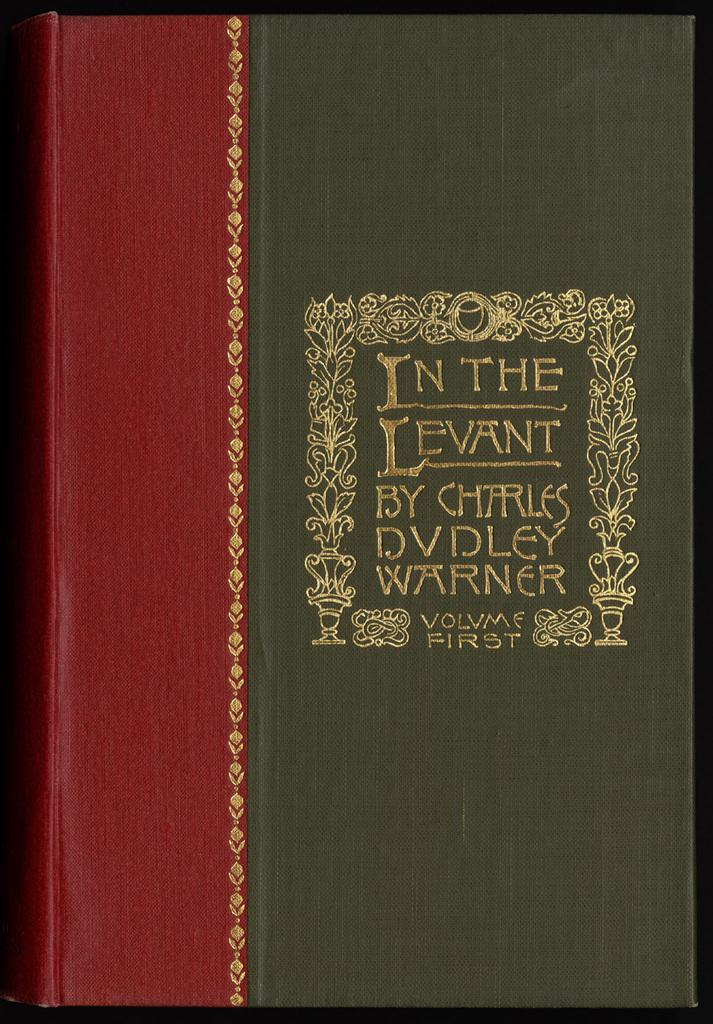<image>
Create a compact narrative representing the image presented. A green and red book says In The Levant By Charles Dudley Warner. 